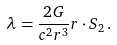<formula> <loc_0><loc_0><loc_500><loc_500>\lambda = \frac { 2 G } { c ^ { 2 } r ^ { 3 } } { r } \cdot { S _ { 2 } } \, .</formula> 